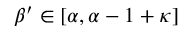Convert formula to latex. <formula><loc_0><loc_0><loc_500><loc_500>\beta ^ { \prime } \in [ \alpha , \alpha - 1 + \kappa ]</formula> 